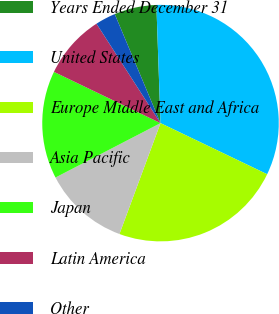<chart> <loc_0><loc_0><loc_500><loc_500><pie_chart><fcel>Years Ended December 31<fcel>United States<fcel>Europe Middle East and Africa<fcel>Asia Pacific<fcel>Japan<fcel>Latin America<fcel>Other<nl><fcel>5.77%<fcel>32.67%<fcel>23.53%<fcel>11.75%<fcel>14.74%<fcel>8.76%<fcel>2.78%<nl></chart> 